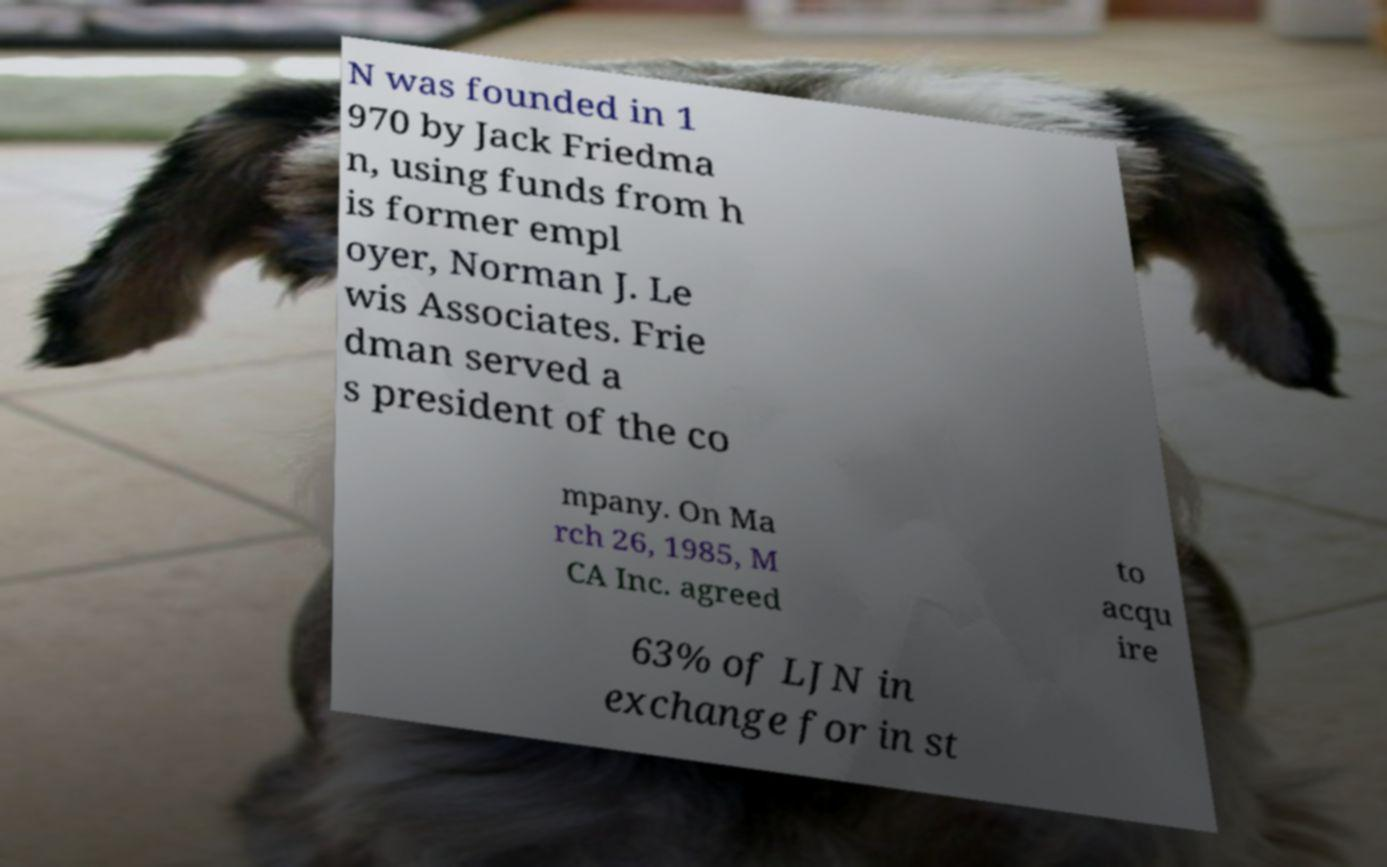There's text embedded in this image that I need extracted. Can you transcribe it verbatim? N was founded in 1 970 by Jack Friedma n, using funds from h is former empl oyer, Norman J. Le wis Associates. Frie dman served a s president of the co mpany. On Ma rch 26, 1985, M CA Inc. agreed to acqu ire 63% of LJN in exchange for in st 